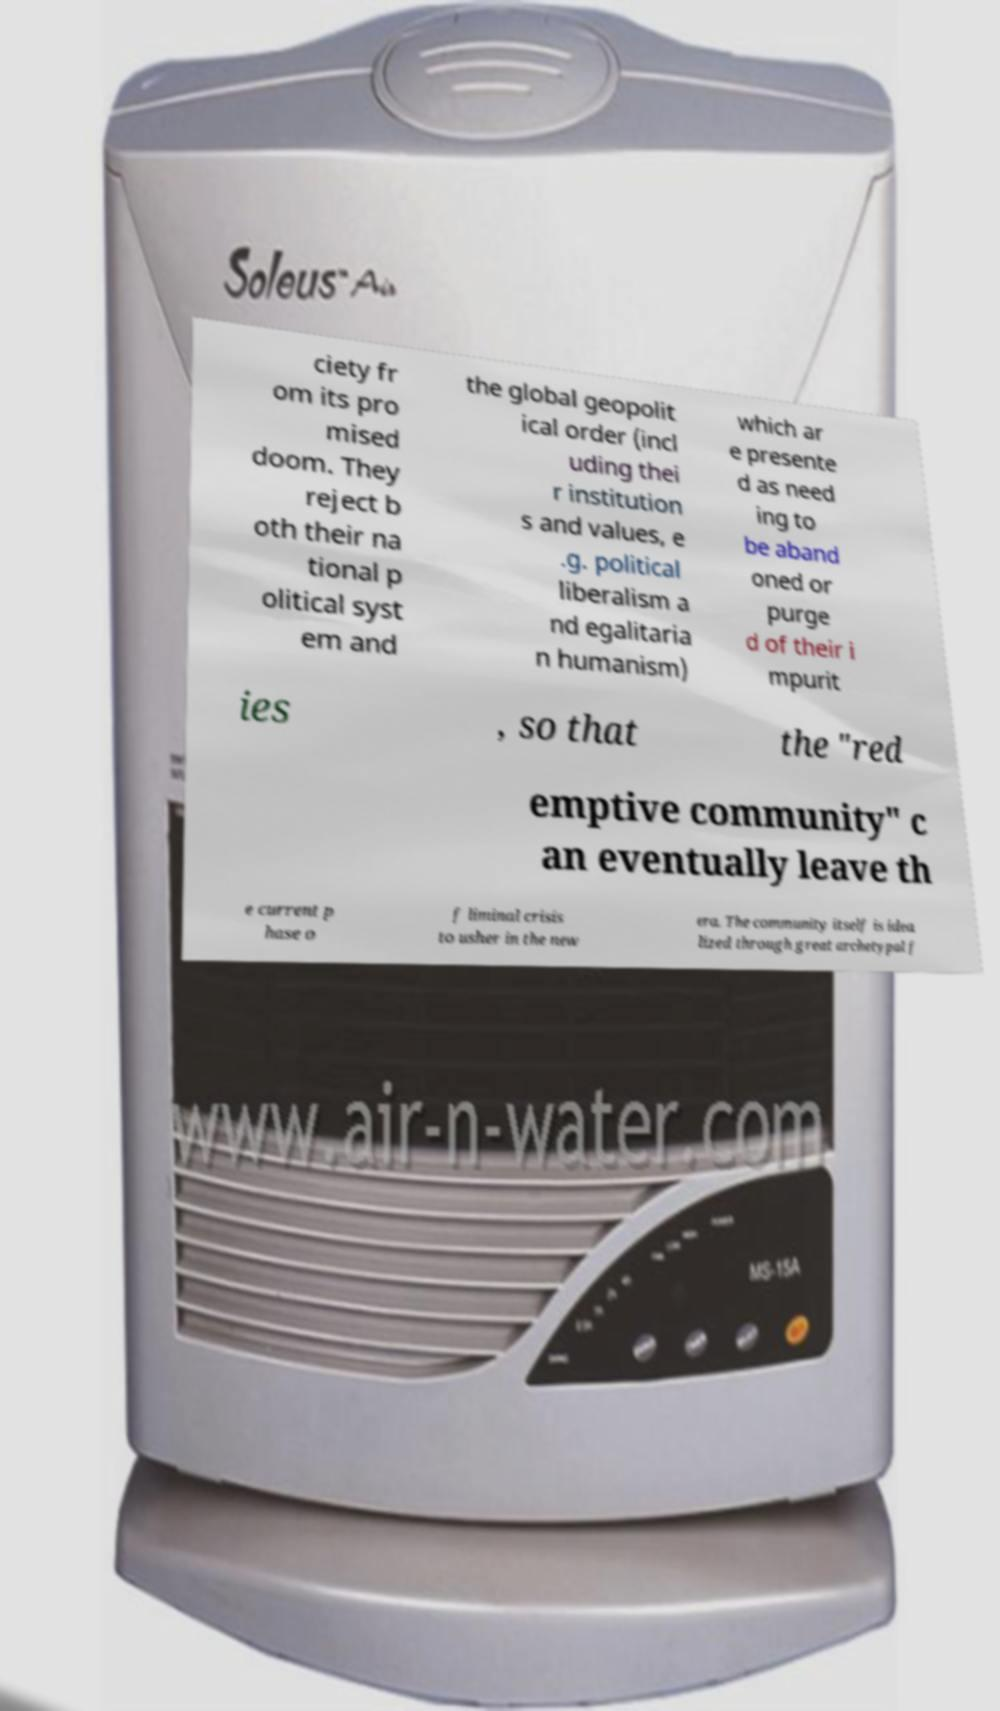For documentation purposes, I need the text within this image transcribed. Could you provide that? ciety fr om its pro mised doom. They reject b oth their na tional p olitical syst em and the global geopolit ical order (incl uding thei r institution s and values, e .g. political liberalism a nd egalitaria n humanism) which ar e presente d as need ing to be aband oned or purge d of their i mpurit ies , so that the "red emptive community" c an eventually leave th e current p hase o f liminal crisis to usher in the new era. The community itself is idea lized through great archetypal f 